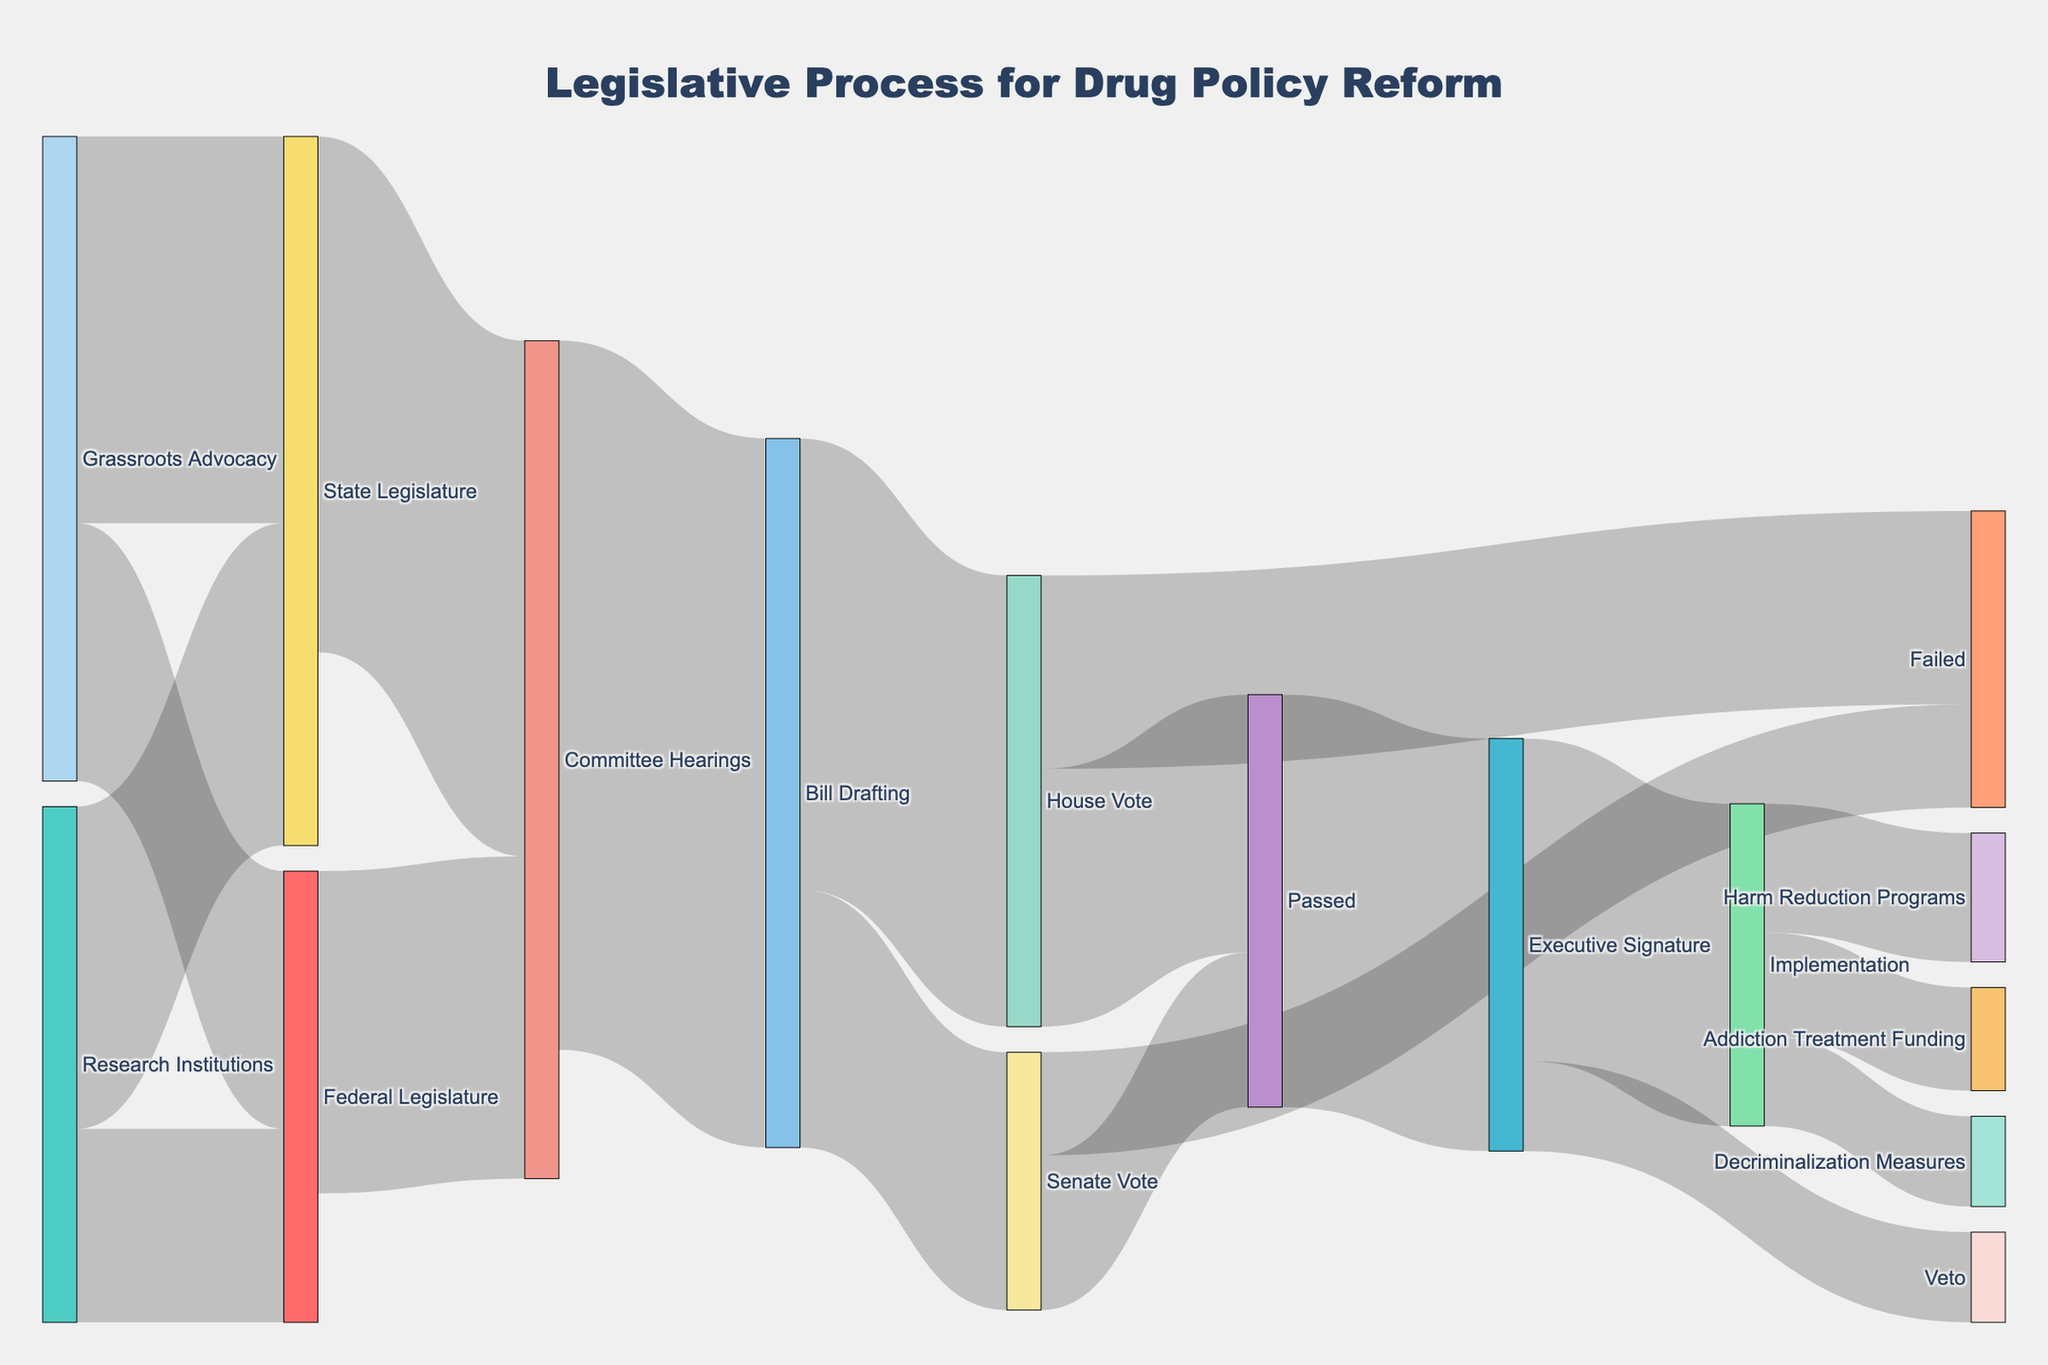What is the title of the Sankey diagram? The title of the diagram is given at the top, it helps to understand the main subject of the figure.
Answer: Legislative Process for Drug Policy Reform How many units of value stem from Grassroots Advocacy to the State Legislature? By looking at the thickness of the link between "Grassroots Advocacy" and "State Legislature," you can see the value written as 30.
Answer: 30 Which step receives the most input from both Research Institutions and Grassroots Advocacy? Summing up the input values to "State Legislature" and "Federal Legislature" from both "Research Institutions" and "Grassroots Advocacy," "State Legislature" receives 55 (30 from Grassroots Advocacy and 25 from Research Institutions) compared to "Federal Legislature" which gets 35 (20 + 15).
Answer: State Legislature How many value units in total are passed from the House Vote stage? From House Vote, a total of 35 units (20 Passed + 15 Failed) are visualized in the links emerging from it.
Answer: 35 Which implementation measure receives the least attention? At the "Implementation" stage, the links to "Harm Reduction Programs," "Addiction Treatment Funding," and "Decriminalization Measures" show values of 10, 8, and 7 respectively, making "Decriminalization Measures" the smallest.
Answer: Decriminalization Measures What is the combined value of executive signatures that lead to Implementation and Veto? Summing up the values from "Executive Signature" to "Implementation" (25) and "Veto" (7) results in a combined value of 32.
Answer: 32 Compare the values that pass Bills from Committee Hearings to House Vote and Senate Vote. Which vote receives more? "House Vote" gets 35, while "Senate Vote" gets 20; House Vote receives more.
Answer: House Vote Which outcome, Passed or Failed, has a higher value after the House Vote? Comparing the values from the House Vote to its outcomes; "Passed" has 20 units, while "Failed" has 15 units. Therefore, Passed has higher value.
Answer: Passed At what stage does the legislation process see the highest number of units being disseminated? By looking at the thickness and values of the links, "Bill Drafting" has a total of 55 units going to House Vote and Senate Vote.
Answer: Bill Drafting 